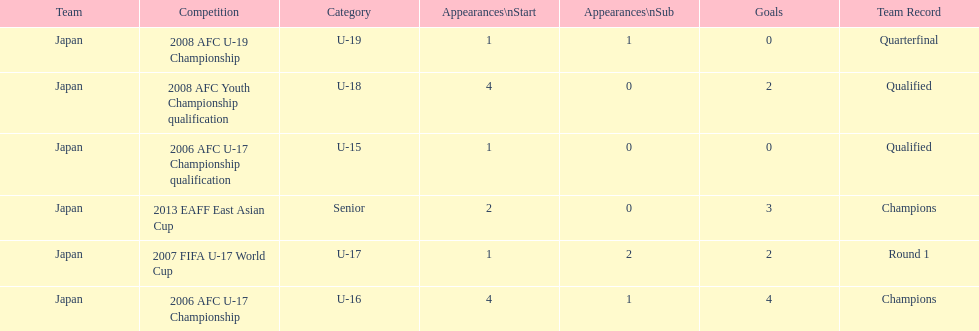What are all of the competitions? 2006 AFC U-17 Championship qualification, 2006 AFC U-17 Championship, 2007 FIFA U-17 World Cup, 2008 AFC Youth Championship qualification, 2008 AFC U-19 Championship, 2013 EAFF East Asian Cup. How many starting appearances were there? 1, 4, 1, 4, 1, 2. What about just during 2013 eaff east asian cup and 2007 fifa u-17 world cup? 1, 2. Which of those had more starting appearances? 2013 EAFF East Asian Cup. 